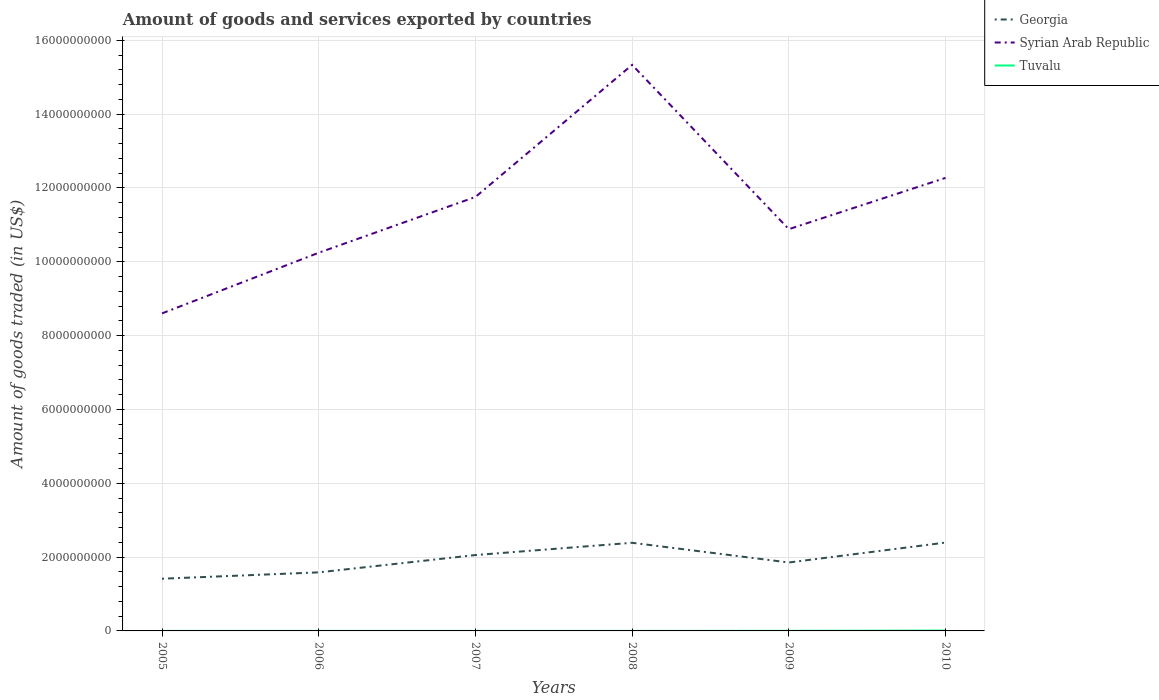How many different coloured lines are there?
Provide a short and direct response. 3. Is the number of lines equal to the number of legend labels?
Your answer should be compact. Yes. Across all years, what is the maximum total amount of goods and services exported in Tuvalu?
Offer a very short reply. 3.37e+05. What is the total total amount of goods and services exported in Tuvalu in the graph?
Provide a short and direct response. -1.42e+05. What is the difference between the highest and the second highest total amount of goods and services exported in Georgia?
Offer a terse response. 9.79e+08. What is the difference between two consecutive major ticks on the Y-axis?
Your response must be concise. 2.00e+09. Are the values on the major ticks of Y-axis written in scientific E-notation?
Offer a terse response. No. Does the graph contain grids?
Provide a succinct answer. Yes. How many legend labels are there?
Provide a short and direct response. 3. What is the title of the graph?
Your answer should be compact. Amount of goods and services exported by countries. What is the label or title of the Y-axis?
Give a very brief answer. Amount of goods traded (in US$). What is the Amount of goods traded (in US$) of Georgia in 2005?
Your answer should be very brief. 1.41e+09. What is the Amount of goods traded (in US$) in Syrian Arab Republic in 2005?
Make the answer very short. 8.60e+09. What is the Amount of goods traded (in US$) in Tuvalu in 2005?
Offer a very short reply. 3.37e+05. What is the Amount of goods traded (in US$) in Georgia in 2006?
Offer a terse response. 1.59e+09. What is the Amount of goods traded (in US$) in Syrian Arab Republic in 2006?
Your answer should be very brief. 1.02e+1. What is the Amount of goods traded (in US$) in Tuvalu in 2006?
Provide a short and direct response. 4.18e+05. What is the Amount of goods traded (in US$) in Georgia in 2007?
Your answer should be compact. 2.06e+09. What is the Amount of goods traded (in US$) of Syrian Arab Republic in 2007?
Provide a succinct answer. 1.18e+1. What is the Amount of goods traded (in US$) in Tuvalu in 2007?
Give a very brief answer. 4.01e+05. What is the Amount of goods traded (in US$) in Georgia in 2008?
Ensure brevity in your answer.  2.39e+09. What is the Amount of goods traded (in US$) in Syrian Arab Republic in 2008?
Make the answer very short. 1.53e+1. What is the Amount of goods traded (in US$) in Tuvalu in 2008?
Your answer should be compact. 5.43e+05. What is the Amount of goods traded (in US$) of Georgia in 2009?
Your answer should be compact. 1.85e+09. What is the Amount of goods traded (in US$) of Syrian Arab Republic in 2009?
Keep it short and to the point. 1.09e+1. What is the Amount of goods traded (in US$) in Tuvalu in 2009?
Provide a succinct answer. 2.57e+06. What is the Amount of goods traded (in US$) in Georgia in 2010?
Offer a terse response. 2.39e+09. What is the Amount of goods traded (in US$) in Syrian Arab Republic in 2010?
Give a very brief answer. 1.23e+1. What is the Amount of goods traded (in US$) of Tuvalu in 2010?
Offer a terse response. 1.00e+07. Across all years, what is the maximum Amount of goods traded (in US$) of Georgia?
Your answer should be very brief. 2.39e+09. Across all years, what is the maximum Amount of goods traded (in US$) of Syrian Arab Republic?
Offer a terse response. 1.53e+1. Across all years, what is the maximum Amount of goods traded (in US$) of Tuvalu?
Give a very brief answer. 1.00e+07. Across all years, what is the minimum Amount of goods traded (in US$) in Georgia?
Offer a terse response. 1.41e+09. Across all years, what is the minimum Amount of goods traded (in US$) in Syrian Arab Republic?
Your response must be concise. 8.60e+09. Across all years, what is the minimum Amount of goods traded (in US$) of Tuvalu?
Your answer should be compact. 3.37e+05. What is the total Amount of goods traded (in US$) of Georgia in the graph?
Your response must be concise. 1.17e+1. What is the total Amount of goods traded (in US$) of Syrian Arab Republic in the graph?
Your response must be concise. 6.91e+1. What is the total Amount of goods traded (in US$) in Tuvalu in the graph?
Your answer should be very brief. 1.43e+07. What is the difference between the Amount of goods traded (in US$) of Georgia in 2005 and that in 2006?
Keep it short and to the point. -1.73e+08. What is the difference between the Amount of goods traded (in US$) of Syrian Arab Republic in 2005 and that in 2006?
Offer a terse response. -1.64e+09. What is the difference between the Amount of goods traded (in US$) of Tuvalu in 2005 and that in 2006?
Provide a short and direct response. -8.12e+04. What is the difference between the Amount of goods traded (in US$) of Georgia in 2005 and that in 2007?
Keep it short and to the point. -6.42e+08. What is the difference between the Amount of goods traded (in US$) of Syrian Arab Republic in 2005 and that in 2007?
Your response must be concise. -3.15e+09. What is the difference between the Amount of goods traded (in US$) of Tuvalu in 2005 and that in 2007?
Provide a succinct answer. -6.40e+04. What is the difference between the Amount of goods traded (in US$) in Georgia in 2005 and that in 2008?
Ensure brevity in your answer.  -9.74e+08. What is the difference between the Amount of goods traded (in US$) of Syrian Arab Republic in 2005 and that in 2008?
Your response must be concise. -6.73e+09. What is the difference between the Amount of goods traded (in US$) of Tuvalu in 2005 and that in 2008?
Provide a short and direct response. -2.06e+05. What is the difference between the Amount of goods traded (in US$) in Georgia in 2005 and that in 2009?
Ensure brevity in your answer.  -4.40e+08. What is the difference between the Amount of goods traded (in US$) of Syrian Arab Republic in 2005 and that in 2009?
Your response must be concise. -2.28e+09. What is the difference between the Amount of goods traded (in US$) in Tuvalu in 2005 and that in 2009?
Provide a succinct answer. -2.24e+06. What is the difference between the Amount of goods traded (in US$) of Georgia in 2005 and that in 2010?
Ensure brevity in your answer.  -9.79e+08. What is the difference between the Amount of goods traded (in US$) in Syrian Arab Republic in 2005 and that in 2010?
Make the answer very short. -3.67e+09. What is the difference between the Amount of goods traded (in US$) in Tuvalu in 2005 and that in 2010?
Your answer should be very brief. -9.68e+06. What is the difference between the Amount of goods traded (in US$) of Georgia in 2006 and that in 2007?
Ensure brevity in your answer.  -4.69e+08. What is the difference between the Amount of goods traded (in US$) in Syrian Arab Republic in 2006 and that in 2007?
Ensure brevity in your answer.  -1.51e+09. What is the difference between the Amount of goods traded (in US$) of Tuvalu in 2006 and that in 2007?
Provide a succinct answer. 1.71e+04. What is the difference between the Amount of goods traded (in US$) in Georgia in 2006 and that in 2008?
Offer a terse response. -8.01e+08. What is the difference between the Amount of goods traded (in US$) in Syrian Arab Republic in 2006 and that in 2008?
Provide a succinct answer. -5.09e+09. What is the difference between the Amount of goods traded (in US$) of Tuvalu in 2006 and that in 2008?
Your response must be concise. -1.25e+05. What is the difference between the Amount of goods traded (in US$) of Georgia in 2006 and that in 2009?
Give a very brief answer. -2.67e+08. What is the difference between the Amount of goods traded (in US$) of Syrian Arab Republic in 2006 and that in 2009?
Your response must be concise. -6.39e+08. What is the difference between the Amount of goods traded (in US$) in Tuvalu in 2006 and that in 2009?
Your response must be concise. -2.16e+06. What is the difference between the Amount of goods traded (in US$) of Georgia in 2006 and that in 2010?
Your answer should be compact. -8.07e+08. What is the difference between the Amount of goods traded (in US$) in Syrian Arab Republic in 2006 and that in 2010?
Your answer should be very brief. -2.03e+09. What is the difference between the Amount of goods traded (in US$) of Tuvalu in 2006 and that in 2010?
Your answer should be compact. -9.60e+06. What is the difference between the Amount of goods traded (in US$) of Georgia in 2007 and that in 2008?
Provide a short and direct response. -3.32e+08. What is the difference between the Amount of goods traded (in US$) of Syrian Arab Republic in 2007 and that in 2008?
Offer a very short reply. -3.58e+09. What is the difference between the Amount of goods traded (in US$) of Tuvalu in 2007 and that in 2008?
Your answer should be very brief. -1.42e+05. What is the difference between the Amount of goods traded (in US$) of Georgia in 2007 and that in 2009?
Provide a short and direct response. 2.02e+08. What is the difference between the Amount of goods traded (in US$) in Syrian Arab Republic in 2007 and that in 2009?
Offer a very short reply. 8.72e+08. What is the difference between the Amount of goods traded (in US$) of Tuvalu in 2007 and that in 2009?
Offer a terse response. -2.17e+06. What is the difference between the Amount of goods traded (in US$) of Georgia in 2007 and that in 2010?
Your response must be concise. -3.38e+08. What is the difference between the Amount of goods traded (in US$) of Syrian Arab Republic in 2007 and that in 2010?
Offer a terse response. -5.17e+08. What is the difference between the Amount of goods traded (in US$) in Tuvalu in 2007 and that in 2010?
Ensure brevity in your answer.  -9.61e+06. What is the difference between the Amount of goods traded (in US$) in Georgia in 2008 and that in 2009?
Your answer should be compact. 5.34e+08. What is the difference between the Amount of goods traded (in US$) of Syrian Arab Republic in 2008 and that in 2009?
Make the answer very short. 4.45e+09. What is the difference between the Amount of goods traded (in US$) in Tuvalu in 2008 and that in 2009?
Your answer should be compact. -2.03e+06. What is the difference between the Amount of goods traded (in US$) of Georgia in 2008 and that in 2010?
Offer a very short reply. -5.67e+06. What is the difference between the Amount of goods traded (in US$) in Syrian Arab Republic in 2008 and that in 2010?
Your answer should be compact. 3.06e+09. What is the difference between the Amount of goods traded (in US$) in Tuvalu in 2008 and that in 2010?
Provide a succinct answer. -9.47e+06. What is the difference between the Amount of goods traded (in US$) in Georgia in 2009 and that in 2010?
Make the answer very short. -5.40e+08. What is the difference between the Amount of goods traded (in US$) in Syrian Arab Republic in 2009 and that in 2010?
Keep it short and to the point. -1.39e+09. What is the difference between the Amount of goods traded (in US$) in Tuvalu in 2009 and that in 2010?
Keep it short and to the point. -7.44e+06. What is the difference between the Amount of goods traded (in US$) in Georgia in 2005 and the Amount of goods traded (in US$) in Syrian Arab Republic in 2006?
Offer a very short reply. -8.83e+09. What is the difference between the Amount of goods traded (in US$) in Georgia in 2005 and the Amount of goods traded (in US$) in Tuvalu in 2006?
Your answer should be very brief. 1.41e+09. What is the difference between the Amount of goods traded (in US$) in Syrian Arab Republic in 2005 and the Amount of goods traded (in US$) in Tuvalu in 2006?
Offer a very short reply. 8.60e+09. What is the difference between the Amount of goods traded (in US$) in Georgia in 2005 and the Amount of goods traded (in US$) in Syrian Arab Republic in 2007?
Keep it short and to the point. -1.03e+1. What is the difference between the Amount of goods traded (in US$) of Georgia in 2005 and the Amount of goods traded (in US$) of Tuvalu in 2007?
Offer a terse response. 1.41e+09. What is the difference between the Amount of goods traded (in US$) of Syrian Arab Republic in 2005 and the Amount of goods traded (in US$) of Tuvalu in 2007?
Offer a terse response. 8.60e+09. What is the difference between the Amount of goods traded (in US$) of Georgia in 2005 and the Amount of goods traded (in US$) of Syrian Arab Republic in 2008?
Your answer should be compact. -1.39e+1. What is the difference between the Amount of goods traded (in US$) of Georgia in 2005 and the Amount of goods traded (in US$) of Tuvalu in 2008?
Keep it short and to the point. 1.41e+09. What is the difference between the Amount of goods traded (in US$) in Syrian Arab Republic in 2005 and the Amount of goods traded (in US$) in Tuvalu in 2008?
Your answer should be very brief. 8.60e+09. What is the difference between the Amount of goods traded (in US$) in Georgia in 2005 and the Amount of goods traded (in US$) in Syrian Arab Republic in 2009?
Make the answer very short. -9.47e+09. What is the difference between the Amount of goods traded (in US$) of Georgia in 2005 and the Amount of goods traded (in US$) of Tuvalu in 2009?
Your answer should be very brief. 1.41e+09. What is the difference between the Amount of goods traded (in US$) of Syrian Arab Republic in 2005 and the Amount of goods traded (in US$) of Tuvalu in 2009?
Ensure brevity in your answer.  8.60e+09. What is the difference between the Amount of goods traded (in US$) in Georgia in 2005 and the Amount of goods traded (in US$) in Syrian Arab Republic in 2010?
Offer a very short reply. -1.09e+1. What is the difference between the Amount of goods traded (in US$) of Georgia in 2005 and the Amount of goods traded (in US$) of Tuvalu in 2010?
Your answer should be compact. 1.40e+09. What is the difference between the Amount of goods traded (in US$) of Syrian Arab Republic in 2005 and the Amount of goods traded (in US$) of Tuvalu in 2010?
Provide a short and direct response. 8.59e+09. What is the difference between the Amount of goods traded (in US$) of Georgia in 2006 and the Amount of goods traded (in US$) of Syrian Arab Republic in 2007?
Your response must be concise. -1.02e+1. What is the difference between the Amount of goods traded (in US$) of Georgia in 2006 and the Amount of goods traded (in US$) of Tuvalu in 2007?
Offer a terse response. 1.59e+09. What is the difference between the Amount of goods traded (in US$) in Syrian Arab Republic in 2006 and the Amount of goods traded (in US$) in Tuvalu in 2007?
Offer a terse response. 1.02e+1. What is the difference between the Amount of goods traded (in US$) of Georgia in 2006 and the Amount of goods traded (in US$) of Syrian Arab Republic in 2008?
Keep it short and to the point. -1.37e+1. What is the difference between the Amount of goods traded (in US$) of Georgia in 2006 and the Amount of goods traded (in US$) of Tuvalu in 2008?
Provide a succinct answer. 1.59e+09. What is the difference between the Amount of goods traded (in US$) of Syrian Arab Republic in 2006 and the Amount of goods traded (in US$) of Tuvalu in 2008?
Offer a very short reply. 1.02e+1. What is the difference between the Amount of goods traded (in US$) of Georgia in 2006 and the Amount of goods traded (in US$) of Syrian Arab Republic in 2009?
Your response must be concise. -9.30e+09. What is the difference between the Amount of goods traded (in US$) of Georgia in 2006 and the Amount of goods traded (in US$) of Tuvalu in 2009?
Provide a short and direct response. 1.58e+09. What is the difference between the Amount of goods traded (in US$) in Syrian Arab Republic in 2006 and the Amount of goods traded (in US$) in Tuvalu in 2009?
Offer a terse response. 1.02e+1. What is the difference between the Amount of goods traded (in US$) in Georgia in 2006 and the Amount of goods traded (in US$) in Syrian Arab Republic in 2010?
Make the answer very short. -1.07e+1. What is the difference between the Amount of goods traded (in US$) of Georgia in 2006 and the Amount of goods traded (in US$) of Tuvalu in 2010?
Ensure brevity in your answer.  1.58e+09. What is the difference between the Amount of goods traded (in US$) of Syrian Arab Republic in 2006 and the Amount of goods traded (in US$) of Tuvalu in 2010?
Your answer should be compact. 1.02e+1. What is the difference between the Amount of goods traded (in US$) in Georgia in 2007 and the Amount of goods traded (in US$) in Syrian Arab Republic in 2008?
Provide a short and direct response. -1.33e+1. What is the difference between the Amount of goods traded (in US$) in Georgia in 2007 and the Amount of goods traded (in US$) in Tuvalu in 2008?
Give a very brief answer. 2.06e+09. What is the difference between the Amount of goods traded (in US$) in Syrian Arab Republic in 2007 and the Amount of goods traded (in US$) in Tuvalu in 2008?
Provide a succinct answer. 1.18e+1. What is the difference between the Amount of goods traded (in US$) of Georgia in 2007 and the Amount of goods traded (in US$) of Syrian Arab Republic in 2009?
Provide a short and direct response. -8.83e+09. What is the difference between the Amount of goods traded (in US$) of Georgia in 2007 and the Amount of goods traded (in US$) of Tuvalu in 2009?
Your response must be concise. 2.05e+09. What is the difference between the Amount of goods traded (in US$) of Syrian Arab Republic in 2007 and the Amount of goods traded (in US$) of Tuvalu in 2009?
Keep it short and to the point. 1.18e+1. What is the difference between the Amount of goods traded (in US$) in Georgia in 2007 and the Amount of goods traded (in US$) in Syrian Arab Republic in 2010?
Give a very brief answer. -1.02e+1. What is the difference between the Amount of goods traded (in US$) of Georgia in 2007 and the Amount of goods traded (in US$) of Tuvalu in 2010?
Offer a very short reply. 2.05e+09. What is the difference between the Amount of goods traded (in US$) of Syrian Arab Republic in 2007 and the Amount of goods traded (in US$) of Tuvalu in 2010?
Offer a very short reply. 1.17e+1. What is the difference between the Amount of goods traded (in US$) in Georgia in 2008 and the Amount of goods traded (in US$) in Syrian Arab Republic in 2009?
Your answer should be very brief. -8.50e+09. What is the difference between the Amount of goods traded (in US$) of Georgia in 2008 and the Amount of goods traded (in US$) of Tuvalu in 2009?
Ensure brevity in your answer.  2.39e+09. What is the difference between the Amount of goods traded (in US$) of Syrian Arab Republic in 2008 and the Amount of goods traded (in US$) of Tuvalu in 2009?
Make the answer very short. 1.53e+1. What is the difference between the Amount of goods traded (in US$) in Georgia in 2008 and the Amount of goods traded (in US$) in Syrian Arab Republic in 2010?
Your answer should be very brief. -9.89e+09. What is the difference between the Amount of goods traded (in US$) in Georgia in 2008 and the Amount of goods traded (in US$) in Tuvalu in 2010?
Give a very brief answer. 2.38e+09. What is the difference between the Amount of goods traded (in US$) in Syrian Arab Republic in 2008 and the Amount of goods traded (in US$) in Tuvalu in 2010?
Your answer should be compact. 1.53e+1. What is the difference between the Amount of goods traded (in US$) of Georgia in 2009 and the Amount of goods traded (in US$) of Syrian Arab Republic in 2010?
Provide a succinct answer. -1.04e+1. What is the difference between the Amount of goods traded (in US$) of Georgia in 2009 and the Amount of goods traded (in US$) of Tuvalu in 2010?
Make the answer very short. 1.84e+09. What is the difference between the Amount of goods traded (in US$) of Syrian Arab Republic in 2009 and the Amount of goods traded (in US$) of Tuvalu in 2010?
Your response must be concise. 1.09e+1. What is the average Amount of goods traded (in US$) of Georgia per year?
Your response must be concise. 1.95e+09. What is the average Amount of goods traded (in US$) in Syrian Arab Republic per year?
Ensure brevity in your answer.  1.15e+1. What is the average Amount of goods traded (in US$) of Tuvalu per year?
Ensure brevity in your answer.  2.38e+06. In the year 2005, what is the difference between the Amount of goods traded (in US$) in Georgia and Amount of goods traded (in US$) in Syrian Arab Republic?
Ensure brevity in your answer.  -7.19e+09. In the year 2005, what is the difference between the Amount of goods traded (in US$) of Georgia and Amount of goods traded (in US$) of Tuvalu?
Ensure brevity in your answer.  1.41e+09. In the year 2005, what is the difference between the Amount of goods traded (in US$) in Syrian Arab Republic and Amount of goods traded (in US$) in Tuvalu?
Your response must be concise. 8.60e+09. In the year 2006, what is the difference between the Amount of goods traded (in US$) of Georgia and Amount of goods traded (in US$) of Syrian Arab Republic?
Give a very brief answer. -8.66e+09. In the year 2006, what is the difference between the Amount of goods traded (in US$) in Georgia and Amount of goods traded (in US$) in Tuvalu?
Offer a terse response. 1.59e+09. In the year 2006, what is the difference between the Amount of goods traded (in US$) of Syrian Arab Republic and Amount of goods traded (in US$) of Tuvalu?
Ensure brevity in your answer.  1.02e+1. In the year 2007, what is the difference between the Amount of goods traded (in US$) of Georgia and Amount of goods traded (in US$) of Syrian Arab Republic?
Offer a very short reply. -9.70e+09. In the year 2007, what is the difference between the Amount of goods traded (in US$) of Georgia and Amount of goods traded (in US$) of Tuvalu?
Offer a terse response. 2.06e+09. In the year 2007, what is the difference between the Amount of goods traded (in US$) of Syrian Arab Republic and Amount of goods traded (in US$) of Tuvalu?
Your answer should be compact. 1.18e+1. In the year 2008, what is the difference between the Amount of goods traded (in US$) of Georgia and Amount of goods traded (in US$) of Syrian Arab Republic?
Your response must be concise. -1.29e+1. In the year 2008, what is the difference between the Amount of goods traded (in US$) of Georgia and Amount of goods traded (in US$) of Tuvalu?
Your answer should be compact. 2.39e+09. In the year 2008, what is the difference between the Amount of goods traded (in US$) in Syrian Arab Republic and Amount of goods traded (in US$) in Tuvalu?
Give a very brief answer. 1.53e+1. In the year 2009, what is the difference between the Amount of goods traded (in US$) in Georgia and Amount of goods traded (in US$) in Syrian Arab Republic?
Provide a succinct answer. -9.03e+09. In the year 2009, what is the difference between the Amount of goods traded (in US$) of Georgia and Amount of goods traded (in US$) of Tuvalu?
Make the answer very short. 1.85e+09. In the year 2009, what is the difference between the Amount of goods traded (in US$) of Syrian Arab Republic and Amount of goods traded (in US$) of Tuvalu?
Offer a terse response. 1.09e+1. In the year 2010, what is the difference between the Amount of goods traded (in US$) of Georgia and Amount of goods traded (in US$) of Syrian Arab Republic?
Keep it short and to the point. -9.88e+09. In the year 2010, what is the difference between the Amount of goods traded (in US$) of Georgia and Amount of goods traded (in US$) of Tuvalu?
Your answer should be compact. 2.38e+09. In the year 2010, what is the difference between the Amount of goods traded (in US$) of Syrian Arab Republic and Amount of goods traded (in US$) of Tuvalu?
Give a very brief answer. 1.23e+1. What is the ratio of the Amount of goods traded (in US$) in Georgia in 2005 to that in 2006?
Make the answer very short. 0.89. What is the ratio of the Amount of goods traded (in US$) in Syrian Arab Republic in 2005 to that in 2006?
Ensure brevity in your answer.  0.84. What is the ratio of the Amount of goods traded (in US$) of Tuvalu in 2005 to that in 2006?
Offer a terse response. 0.81. What is the ratio of the Amount of goods traded (in US$) of Georgia in 2005 to that in 2007?
Your response must be concise. 0.69. What is the ratio of the Amount of goods traded (in US$) in Syrian Arab Republic in 2005 to that in 2007?
Your answer should be compact. 0.73. What is the ratio of the Amount of goods traded (in US$) of Tuvalu in 2005 to that in 2007?
Offer a terse response. 0.84. What is the ratio of the Amount of goods traded (in US$) in Georgia in 2005 to that in 2008?
Make the answer very short. 0.59. What is the ratio of the Amount of goods traded (in US$) of Syrian Arab Republic in 2005 to that in 2008?
Offer a very short reply. 0.56. What is the ratio of the Amount of goods traded (in US$) of Tuvalu in 2005 to that in 2008?
Your response must be concise. 0.62. What is the ratio of the Amount of goods traded (in US$) of Georgia in 2005 to that in 2009?
Keep it short and to the point. 0.76. What is the ratio of the Amount of goods traded (in US$) of Syrian Arab Republic in 2005 to that in 2009?
Provide a short and direct response. 0.79. What is the ratio of the Amount of goods traded (in US$) of Tuvalu in 2005 to that in 2009?
Offer a very short reply. 0.13. What is the ratio of the Amount of goods traded (in US$) of Georgia in 2005 to that in 2010?
Your answer should be compact. 0.59. What is the ratio of the Amount of goods traded (in US$) of Syrian Arab Republic in 2005 to that in 2010?
Offer a very short reply. 0.7. What is the ratio of the Amount of goods traded (in US$) in Tuvalu in 2005 to that in 2010?
Make the answer very short. 0.03. What is the ratio of the Amount of goods traded (in US$) in Georgia in 2006 to that in 2007?
Your answer should be very brief. 0.77. What is the ratio of the Amount of goods traded (in US$) of Syrian Arab Republic in 2006 to that in 2007?
Your answer should be compact. 0.87. What is the ratio of the Amount of goods traded (in US$) in Tuvalu in 2006 to that in 2007?
Your answer should be compact. 1.04. What is the ratio of the Amount of goods traded (in US$) of Georgia in 2006 to that in 2008?
Keep it short and to the point. 0.66. What is the ratio of the Amount of goods traded (in US$) in Syrian Arab Republic in 2006 to that in 2008?
Ensure brevity in your answer.  0.67. What is the ratio of the Amount of goods traded (in US$) in Tuvalu in 2006 to that in 2008?
Give a very brief answer. 0.77. What is the ratio of the Amount of goods traded (in US$) in Georgia in 2006 to that in 2009?
Offer a terse response. 0.86. What is the ratio of the Amount of goods traded (in US$) of Syrian Arab Republic in 2006 to that in 2009?
Offer a very short reply. 0.94. What is the ratio of the Amount of goods traded (in US$) in Tuvalu in 2006 to that in 2009?
Provide a short and direct response. 0.16. What is the ratio of the Amount of goods traded (in US$) in Georgia in 2006 to that in 2010?
Your answer should be compact. 0.66. What is the ratio of the Amount of goods traded (in US$) in Syrian Arab Republic in 2006 to that in 2010?
Make the answer very short. 0.83. What is the ratio of the Amount of goods traded (in US$) of Tuvalu in 2006 to that in 2010?
Your response must be concise. 0.04. What is the ratio of the Amount of goods traded (in US$) in Georgia in 2007 to that in 2008?
Offer a very short reply. 0.86. What is the ratio of the Amount of goods traded (in US$) in Syrian Arab Republic in 2007 to that in 2008?
Offer a very short reply. 0.77. What is the ratio of the Amount of goods traded (in US$) of Tuvalu in 2007 to that in 2008?
Give a very brief answer. 0.74. What is the ratio of the Amount of goods traded (in US$) in Georgia in 2007 to that in 2009?
Offer a terse response. 1.11. What is the ratio of the Amount of goods traded (in US$) in Syrian Arab Republic in 2007 to that in 2009?
Provide a succinct answer. 1.08. What is the ratio of the Amount of goods traded (in US$) of Tuvalu in 2007 to that in 2009?
Your response must be concise. 0.16. What is the ratio of the Amount of goods traded (in US$) of Georgia in 2007 to that in 2010?
Keep it short and to the point. 0.86. What is the ratio of the Amount of goods traded (in US$) in Syrian Arab Republic in 2007 to that in 2010?
Your response must be concise. 0.96. What is the ratio of the Amount of goods traded (in US$) in Georgia in 2008 to that in 2009?
Ensure brevity in your answer.  1.29. What is the ratio of the Amount of goods traded (in US$) in Syrian Arab Republic in 2008 to that in 2009?
Give a very brief answer. 1.41. What is the ratio of the Amount of goods traded (in US$) in Tuvalu in 2008 to that in 2009?
Give a very brief answer. 0.21. What is the ratio of the Amount of goods traded (in US$) of Syrian Arab Republic in 2008 to that in 2010?
Your answer should be compact. 1.25. What is the ratio of the Amount of goods traded (in US$) of Tuvalu in 2008 to that in 2010?
Make the answer very short. 0.05. What is the ratio of the Amount of goods traded (in US$) of Georgia in 2009 to that in 2010?
Ensure brevity in your answer.  0.77. What is the ratio of the Amount of goods traded (in US$) of Syrian Arab Republic in 2009 to that in 2010?
Your answer should be very brief. 0.89. What is the ratio of the Amount of goods traded (in US$) of Tuvalu in 2009 to that in 2010?
Your response must be concise. 0.26. What is the difference between the highest and the second highest Amount of goods traded (in US$) in Georgia?
Make the answer very short. 5.67e+06. What is the difference between the highest and the second highest Amount of goods traded (in US$) in Syrian Arab Republic?
Make the answer very short. 3.06e+09. What is the difference between the highest and the second highest Amount of goods traded (in US$) of Tuvalu?
Your answer should be very brief. 7.44e+06. What is the difference between the highest and the lowest Amount of goods traded (in US$) in Georgia?
Provide a succinct answer. 9.79e+08. What is the difference between the highest and the lowest Amount of goods traded (in US$) in Syrian Arab Republic?
Ensure brevity in your answer.  6.73e+09. What is the difference between the highest and the lowest Amount of goods traded (in US$) of Tuvalu?
Provide a succinct answer. 9.68e+06. 